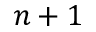Convert formula to latex. <formula><loc_0><loc_0><loc_500><loc_500>n + 1</formula> 